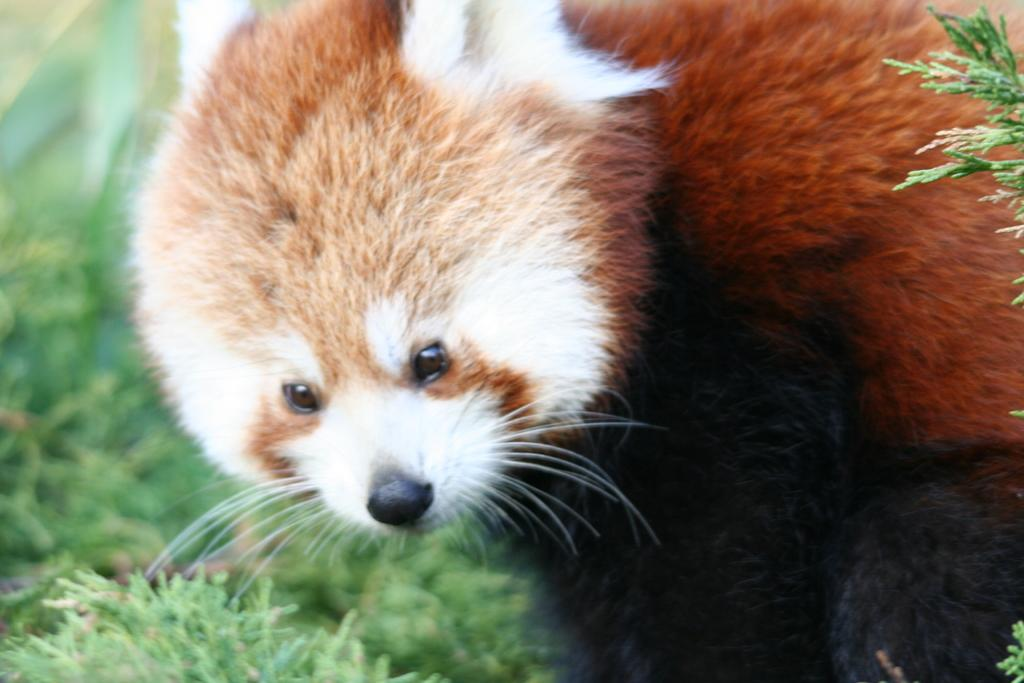What type of animal is present in the image? There is an animal in the image. Can you describe the color pattern of the animal? The animal is brown, black, and white in color. Where is the animal located in the image? The animal is on the grass. What type of oil is being used to punish the animal in the image? There is no oil or punishment present in the image; it features an animal on the grass. How many doors can be seen in the image? There are no doors present in the image. 